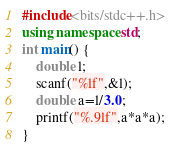Convert code to text. <code><loc_0><loc_0><loc_500><loc_500><_C++_>#include<bits/stdc++.h>
using namespace std;
int main() {
    double l;
    scanf("%lf",&l);
    double a=l/3.0;
    printf("%.9lf",a*a*a);
}
</code> 